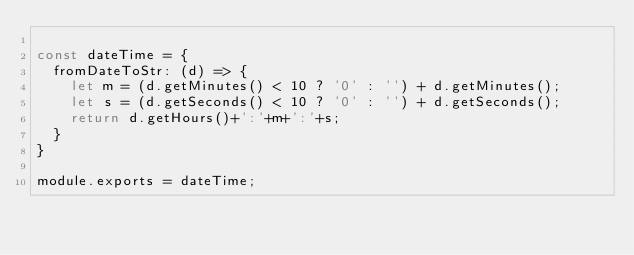Convert code to text. <code><loc_0><loc_0><loc_500><loc_500><_JavaScript_>
const dateTime = {
  fromDateToStr: (d) => {
    let m = (d.getMinutes() < 10 ? '0' : '') + d.getMinutes();
    let s = (d.getSeconds() < 10 ? '0' : '') + d.getSeconds();
    return d.getHours()+':'+m+':'+s;
  }
}

module.exports = dateTime;
</code> 